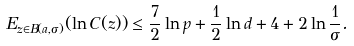Convert formula to latex. <formula><loc_0><loc_0><loc_500><loc_500>E _ { z \in B ( a , \sigma ) } ( \ln C ( z ) ) \leq \frac { 7 } { 2 } \ln p + \frac { 1 } { 2 } \ln d + 4 + 2 \ln \frac { 1 } { \sigma } .</formula> 